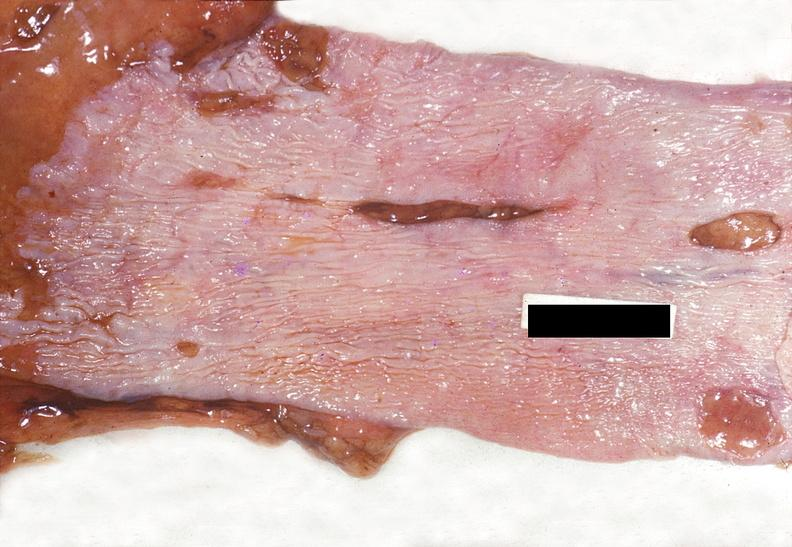s gastrointestinal present?
Answer the question using a single word or phrase. Yes 